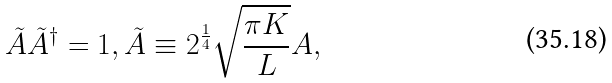<formula> <loc_0><loc_0><loc_500><loc_500>\tilde { A } \tilde { A } ^ { \dagger } = 1 , \tilde { A } \equiv 2 ^ { \frac { 1 } { 4 } } \sqrt { \frac { \pi K } { L } } A ,</formula> 